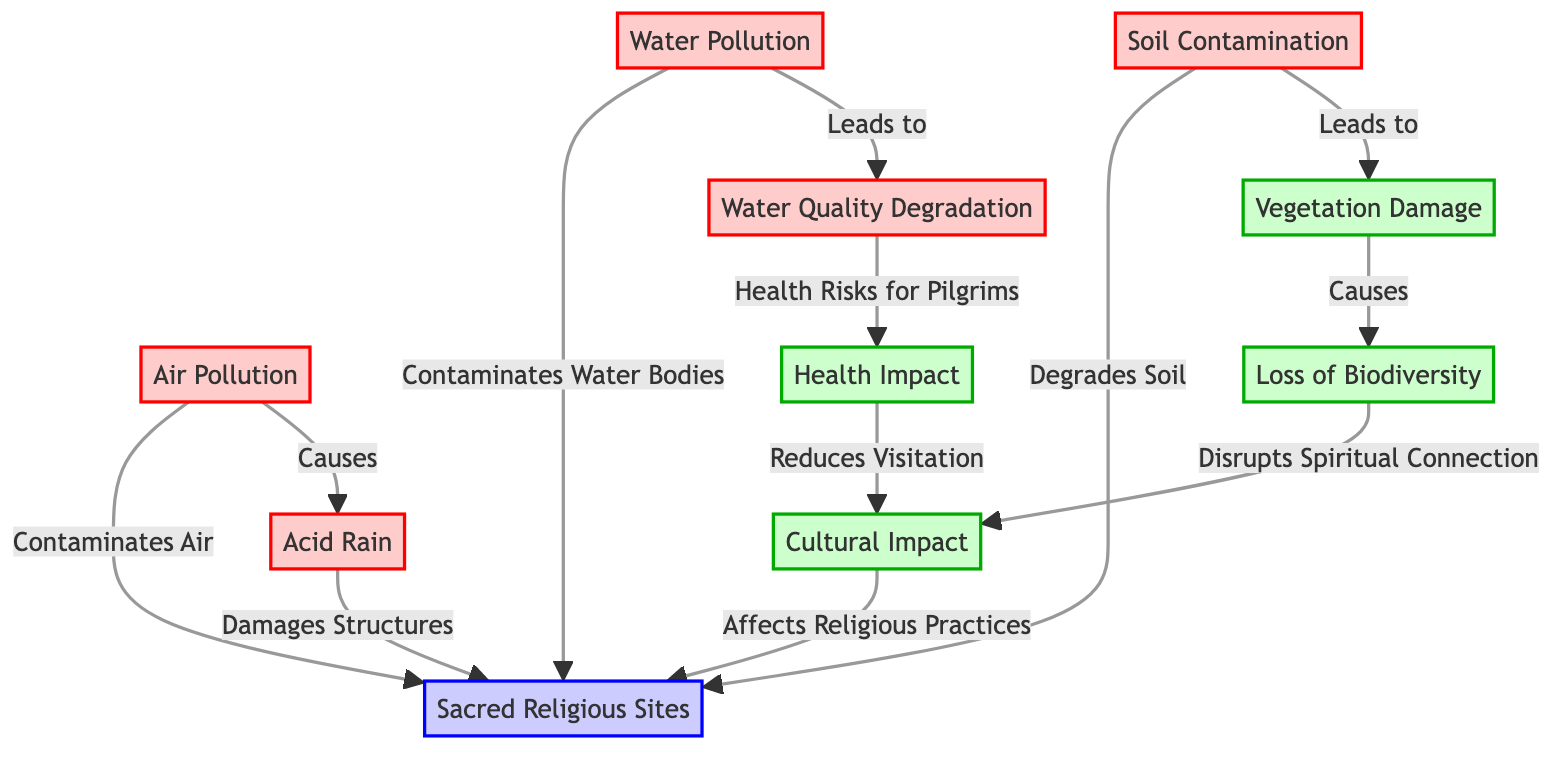What pollutants are shown impacting the sacred sites? The diagram indicates four pollutants affecting sacred sites: Air Pollution, Water Pollution, Soil Contamination, and Acid Rain. These nodes are visually distinct and labeled accordingly.
Answer: Air Pollution, Water Pollution, Soil Contamination, Acid Rain How does Air Pollution affect Sacred Religious Sites? Air Pollution directly contaminates the air surrounding the Sacred Sites and additionally causes Acid Rain, which further damages the structures of these sites. This relationship is illustrated with arrows indicating the flow of impact from Air Pollution to both Sacred Sites and Acid Rain.
Answer: Contaminates Air, Causes How many impacts are directly associated with Sacred Religious Sites? There are four impacts directly linked to Sacred Religious Sites, which are: Cultural Impact, Health Impact, Loss of Biodiversity, and Vegetation Damage. These relationships are shown through directed arrows connecting impacts to Sacred Sites.
Answer: Four What consequence does Water Pollution lead to in terms of health? Water Pollution leads to Water Quality Degradation, which poses Health Risks for Pilgrims. This relationship is evident as Water Pollution connects to both Water Quality Degradation and further to Health Impact.
Answer: Health Risks for Pilgrims What is the relationship between Loss of Biodiversity and Cultural Impact? Loss of Biodiversity disrupts the Spiritual Connection, which in turn affects Cultural Impact. This flow can be traced through the arrows that connect these nodes in the diagram, indicating a cascading effect from Loss of Biodiversity to Cultural Impact.
Answer: Disrupts Spiritual Connection What types of degradation are shown as a result of environmental pollutants? The diagram illustrates three types of degradation caused by environmental pollutants: Soil Degradation (from Soil Contamination), Water Quality Degradation (from Water Pollution), and Vegetation Damage (also from Soil Contamination). This information can be gathered by tracing the arrows from the pollutants to these degradation types.
Answer: Soil, Water, Vegetation How does Soil Contamination influence Sacred Sites? Soil Contamination degrades the soil quality, leading to Vegetation Damage, which directly impacts the Sacred Sites. This impact chain is represented in the diagram, showing the directional relationship from Soil Contamination to both the degradation and the Sacred Sites.
Answer: Degrades Soil What impact does Acid Rain have on Sacred Religious Sites? Acid Rain damages the structures of Sacred Religious Sites, as indicated by an arrow connecting Acid Rain to Sacred Sites in the diagram. This suggests a direct negative effect from this type of pollution specifically on the physical structures.
Answer: Damages Structures 